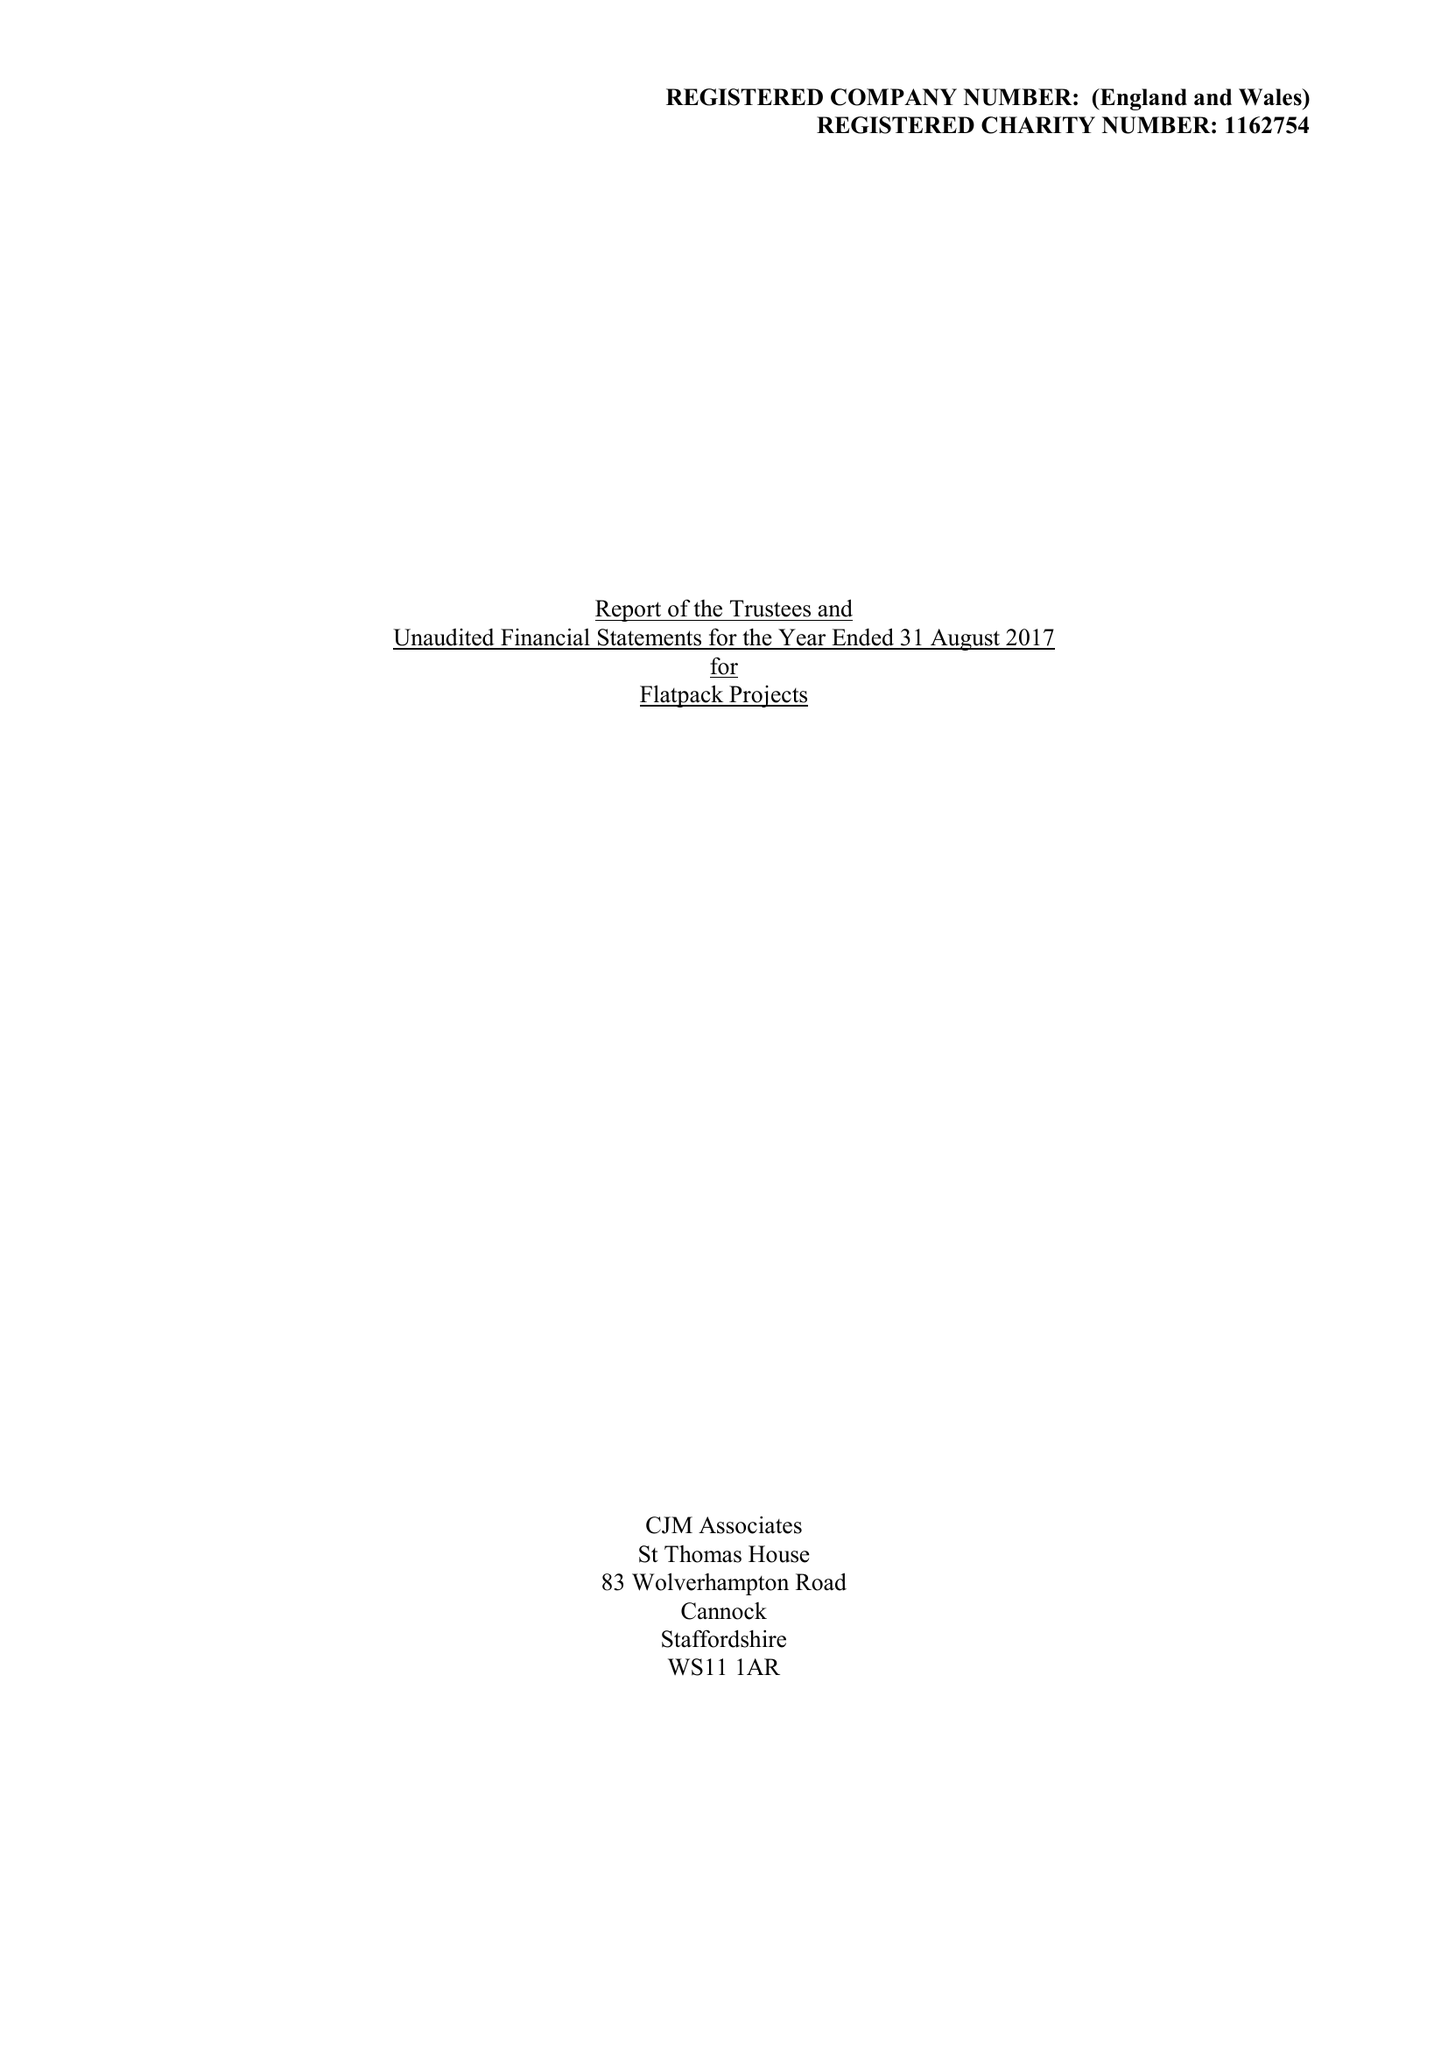What is the value for the spending_annually_in_british_pounds?
Answer the question using a single word or phrase. 375808.00 